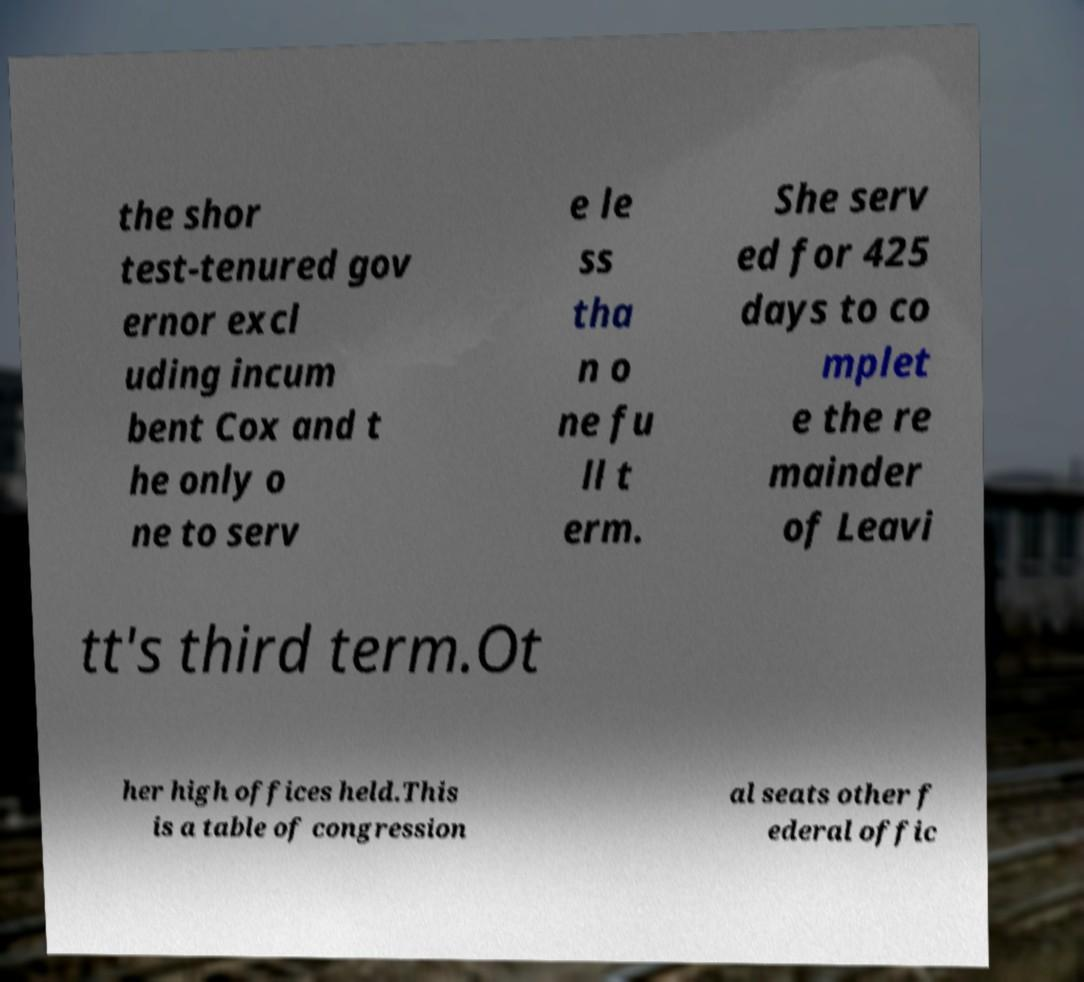Can you read and provide the text displayed in the image?This photo seems to have some interesting text. Can you extract and type it out for me? the shor test-tenured gov ernor excl uding incum bent Cox and t he only o ne to serv e le ss tha n o ne fu ll t erm. She serv ed for 425 days to co mplet e the re mainder of Leavi tt's third term.Ot her high offices held.This is a table of congression al seats other f ederal offic 